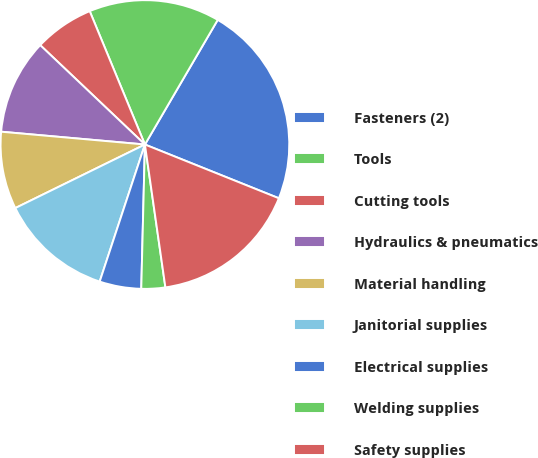Convert chart. <chart><loc_0><loc_0><loc_500><loc_500><pie_chart><fcel>Fasteners (2)<fcel>Tools<fcel>Cutting tools<fcel>Hydraulics & pneumatics<fcel>Material handling<fcel>Janitorial supplies<fcel>Electrical supplies<fcel>Welding supplies<fcel>Safety supplies<nl><fcel>22.66%<fcel>14.66%<fcel>6.67%<fcel>10.67%<fcel>8.67%<fcel>12.67%<fcel>4.67%<fcel>2.67%<fcel>16.66%<nl></chart> 